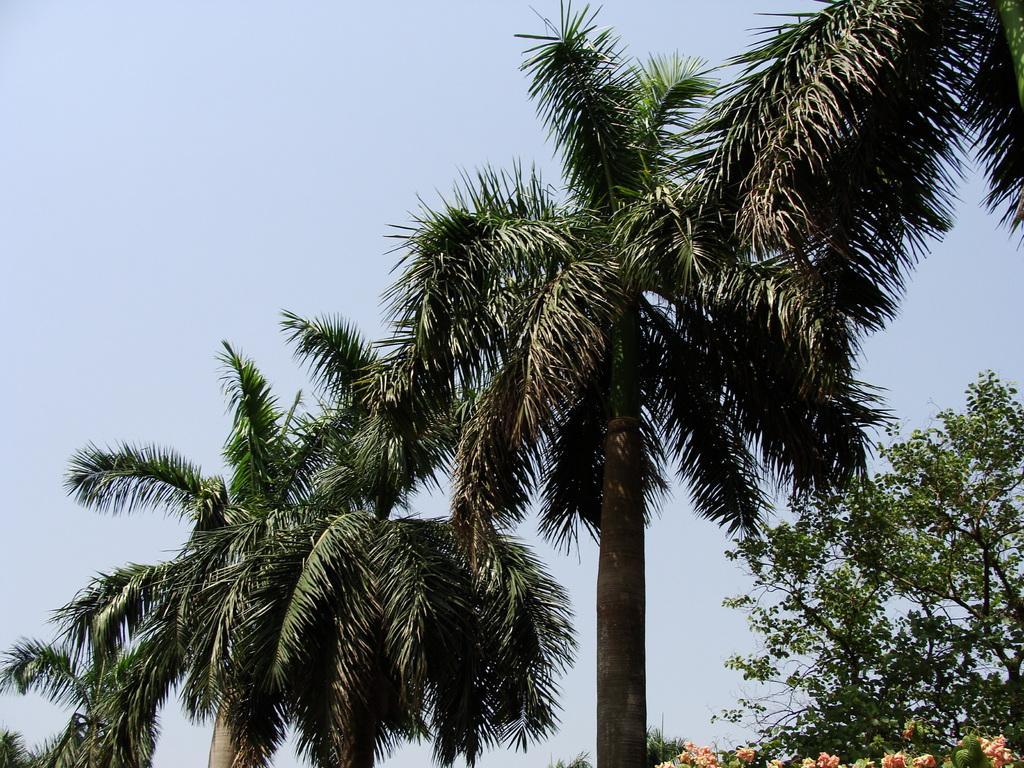Please provide a concise description of this image. In this picture we can see flowers, trees and in the background we can see the sky. 